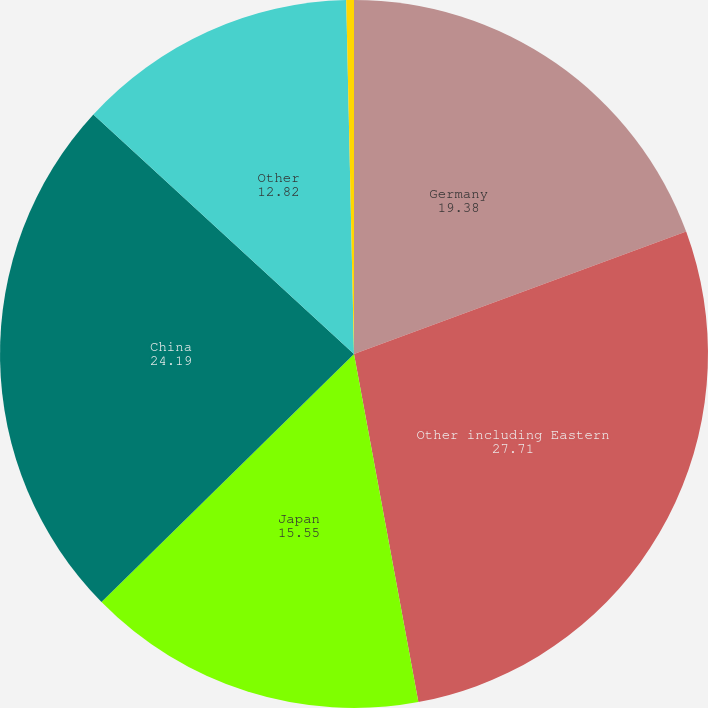<chart> <loc_0><loc_0><loc_500><loc_500><pie_chart><fcel>Germany<fcel>Other including Eastern<fcel>Japan<fcel>China<fcel>Other<fcel>Rest of the World<nl><fcel>19.38%<fcel>27.71%<fcel>15.55%<fcel>24.19%<fcel>12.82%<fcel>0.35%<nl></chart> 